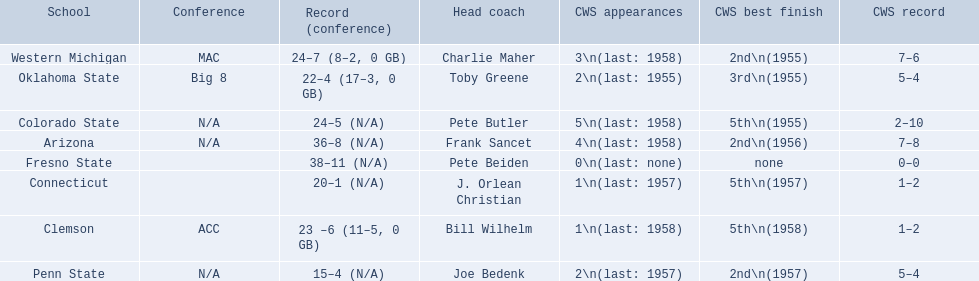What are the listed schools? Arizona, Clemson, Colorado State, Connecticut, Fresno State, Oklahoma State, Penn State, Western Michigan. Which are clemson and western michigan? Clemson, Western Michigan. What are their corresponding numbers of cws appearances? 1\n(last: 1958), 3\n(last: 1958). Which value is larger? 3\n(last: 1958). To which school does that value belong to? Western Michigan. 